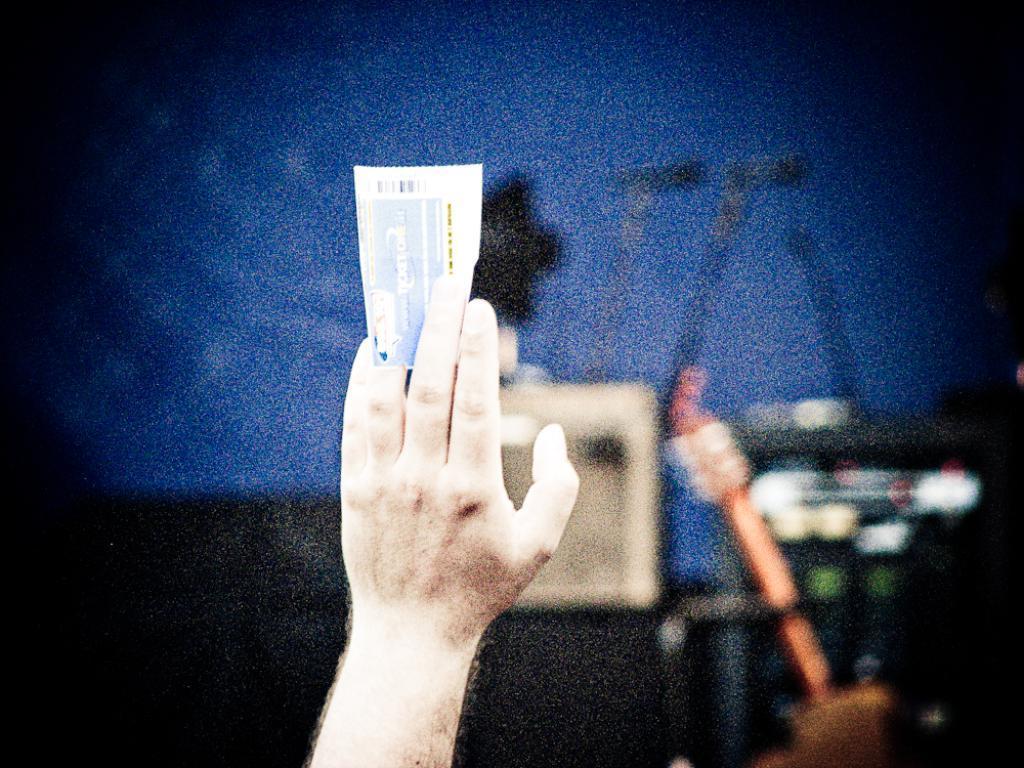Can you describe this image briefly? In this image we can see the hand of a person holding a paper. We can also see blurred background. 